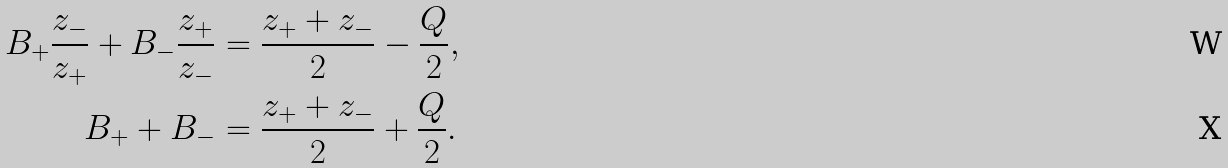<formula> <loc_0><loc_0><loc_500><loc_500>B _ { + } \frac { z _ { - } } { z _ { + } } + B _ { - } \frac { z _ { + } } { z _ { - } } & = \frac { z _ { + } + z _ { - } } { 2 } - \frac { Q } { 2 } , \\ B _ { + } + B _ { - } & = \frac { z _ { + } + z _ { - } } { 2 } + \frac { Q } { 2 } .</formula> 